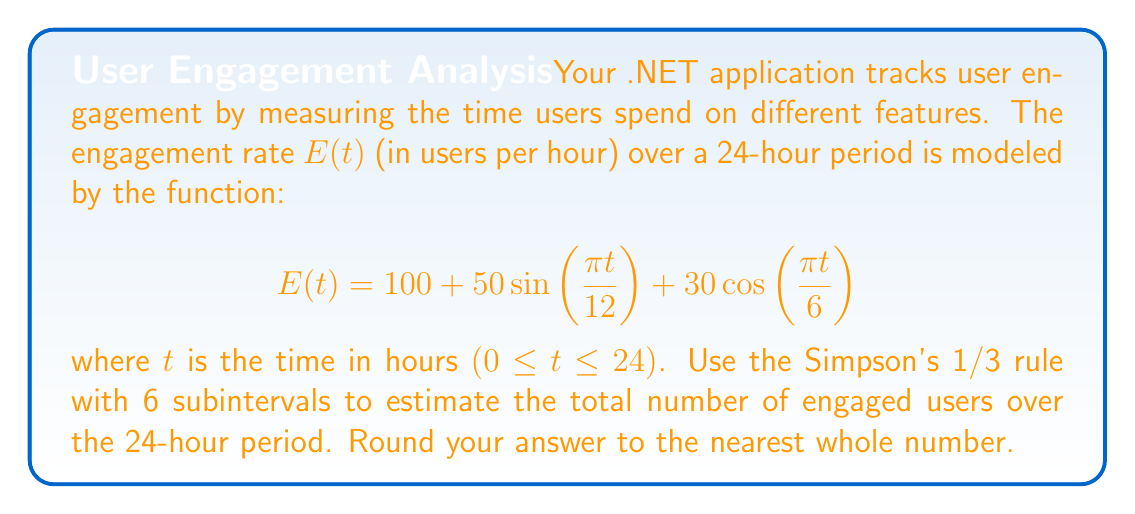Teach me how to tackle this problem. To solve this problem using Simpson's 1/3 rule with 6 subintervals, we'll follow these steps:

1) Simpson's 1/3 rule for n subintervals is given by:

   $$\int_a^b f(x)dx \approx \frac{h}{3}[f(x_0) + 4f(x_1) + 2f(x_2) + 4f(x_3) + 2f(x_4) + 4f(x_5) + f(x_6)]$$

   where $h = \frac{b-a}{n}$, and $x_i = a + ih$ for $i = 0, 1, ..., n$

2) In our case, $a = 0$, $b = 24$, and $n = 6$. So, $h = \frac{24-0}{6} = 4$

3) We need to evaluate $E(t)$ at $t = 0, 4, 8, 12, 16, 20, 24$:

   $E(0) = 100 + 50\sin(0) + 30\cos(0) = 130$
   $E(4) = 100 + 50\sin(\frac{\pi}{3}) + 30\cos(\frac{\pi}{3}) \approx 143.30$
   $E(8) = 100 + 50\sin(\frac{2\pi}{3}) + 30\cos(\frac{2\pi}{3}) \approx 143.30$
   $E(12) = 100 + 50\sin(\pi) + 30\cos(\pi) = 70$
   $E(16) = 100 + 50\sin(\frac{4\pi}{3}) + 30\cos(\frac{4\pi}{3}) \approx 56.70$
   $E(20) = 100 + 50\sin(\frac{5\pi}{3}) + 30\cos(\frac{5\pi}{3}) \approx 56.70$
   $E(24) = 100 + 50\sin(2\pi) + 30\cos(2\pi) = 130$

4) Applying Simpson's 1/3 rule:

   $$\int_0^{24} E(t)dt \approx \frac{4}{3}[130 + 4(143.30) + 2(143.30) + 4(70) + 2(56.70) + 4(56.70) + 130]$$

5) Simplifying:

   $$\approx \frac{4}{3}[130 + 573.20 + 286.60 + 280 + 113.40 + 226.80 + 130]$$
   $$= \frac{4}{3}[1740]$$
   $$= 2320$$

6) The result 2320 represents the total number of engaged user-hours over the 24-hour period.
Answer: 2320 users 